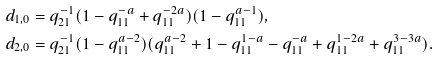<formula> <loc_0><loc_0><loc_500><loc_500>d _ { 1 , 0 } & = q _ { 2 1 } ^ { - 1 } ( 1 - q _ { 1 1 } ^ { - a } + q _ { 1 1 } ^ { - 2 a } ) ( 1 - q _ { 1 1 } ^ { a - 1 } ) , \\ d _ { 2 , 0 } & = q _ { 2 1 } ^ { - 1 } ( 1 - q _ { 1 1 } ^ { a - 2 } ) ( q _ { 1 1 } ^ { a - 2 } + 1 - q _ { 1 1 } ^ { 1 - a } - q _ { 1 1 } ^ { - a } + q _ { 1 1 } ^ { 1 - 2 a } + q _ { 1 1 } ^ { 3 - 3 a } ) .</formula> 